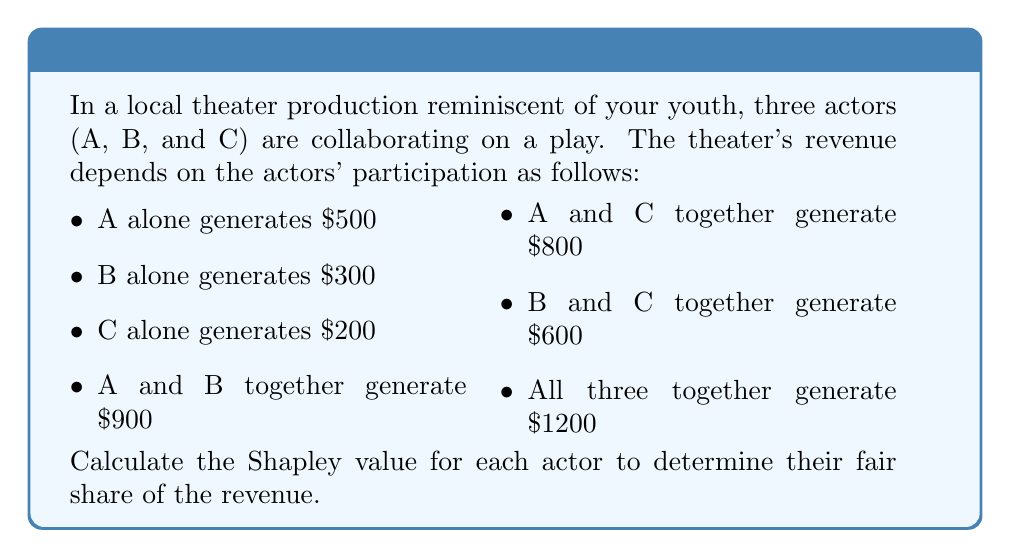Can you answer this question? To calculate the Shapley value, we need to consider all possible coalitions and the marginal contributions of each actor. Let's go through this step-by-step:

1. List all possible coalitions and their values:
   $v(\emptyset) = 0$
   $v(A) = 500$
   $v(B) = 300$
   $v(C) = 200$
   $v(AB) = 900$
   $v(AC) = 800$
   $v(BC) = 600$
   $v(ABC) = 1200$

2. Calculate marginal contributions for each actor in every possible order:

   ABC: A = 500, B = 400, C = 300
   ACB: A = 500, C = 300, B = 400
   BAC: B = 300, A = 600, C = 300
   BCA: B = 300, C = 300, A = 600
   CAB: C = 200, A = 600, B = 400
   CBA: C = 200, B = 400, A = 600

3. Calculate the average marginal contribution for each actor:

   Actor A: $\frac{500 + 500 + 600 + 600 + 600 + 600}{6} = 566.67$
   Actor B: $\frac{400 + 400 + 300 + 300 + 400 + 400}{6} = 366.67$
   Actor C: $\frac{300 + 300 + 300 + 300 + 200 + 200}{6} = 266.67$

4. Verify that the sum of Shapley values equals the total value:
   $566.67 + 366.67 + 266.67 = 1200$

Therefore, the Shapley values for actors A, B, and C are approximately $566.67, $366.67, and $266.67, respectively.
Answer: A: $566.67, B: $366.67, C: $266.67 